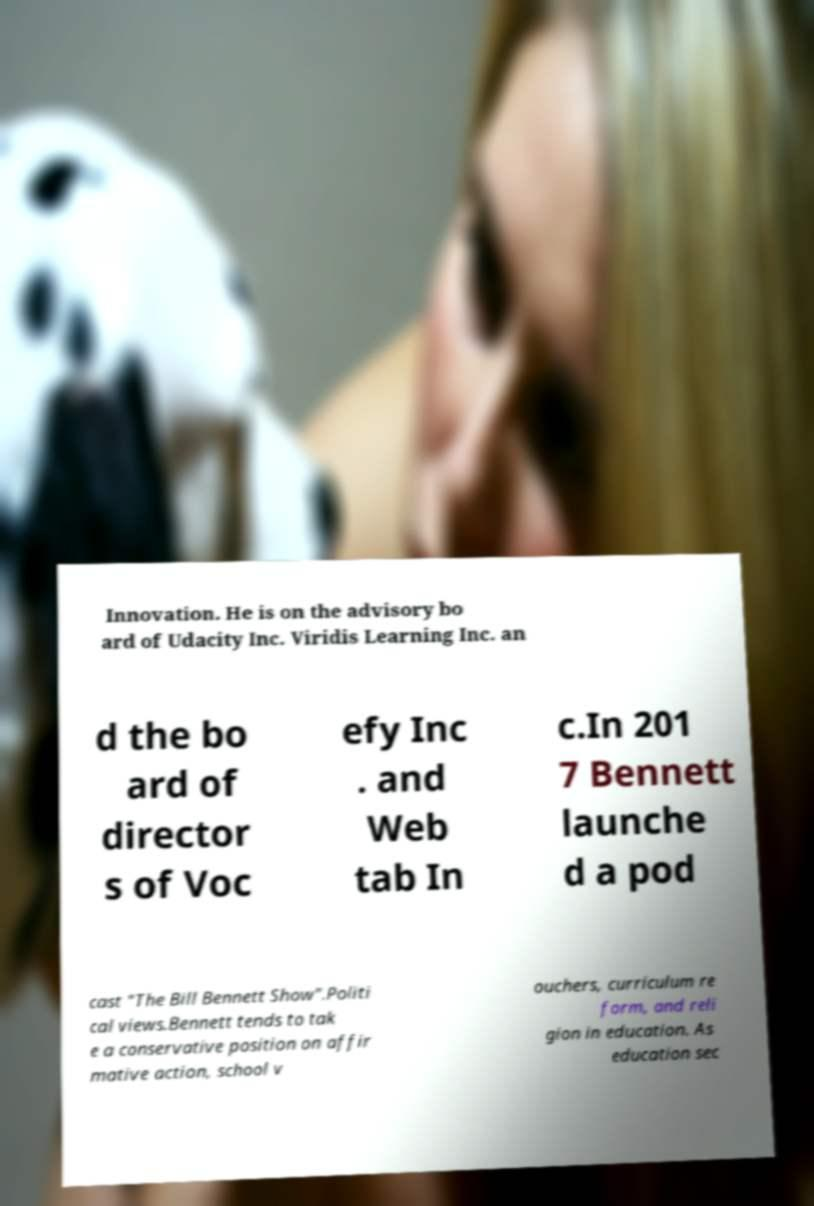Please identify and transcribe the text found in this image. Innovation. He is on the advisory bo ard of Udacity Inc. Viridis Learning Inc. an d the bo ard of director s of Voc efy Inc . and Web tab In c.In 201 7 Bennett launche d a pod cast "The Bill Bennett Show".Politi cal views.Bennett tends to tak e a conservative position on affir mative action, school v ouchers, curriculum re form, and reli gion in education. As education sec 